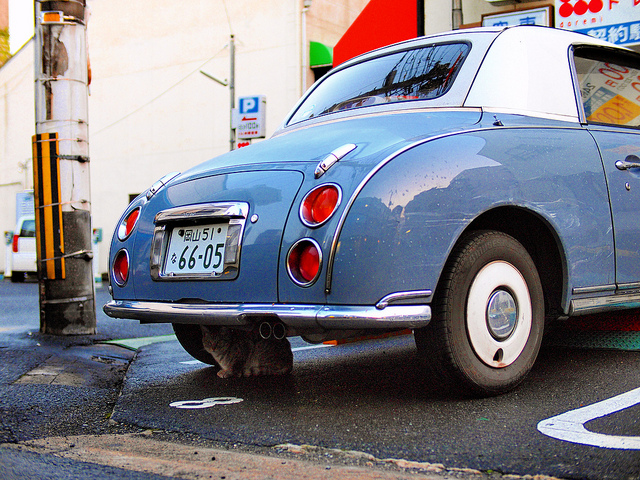Identify the text contained in this image. P 66-05 8 100 